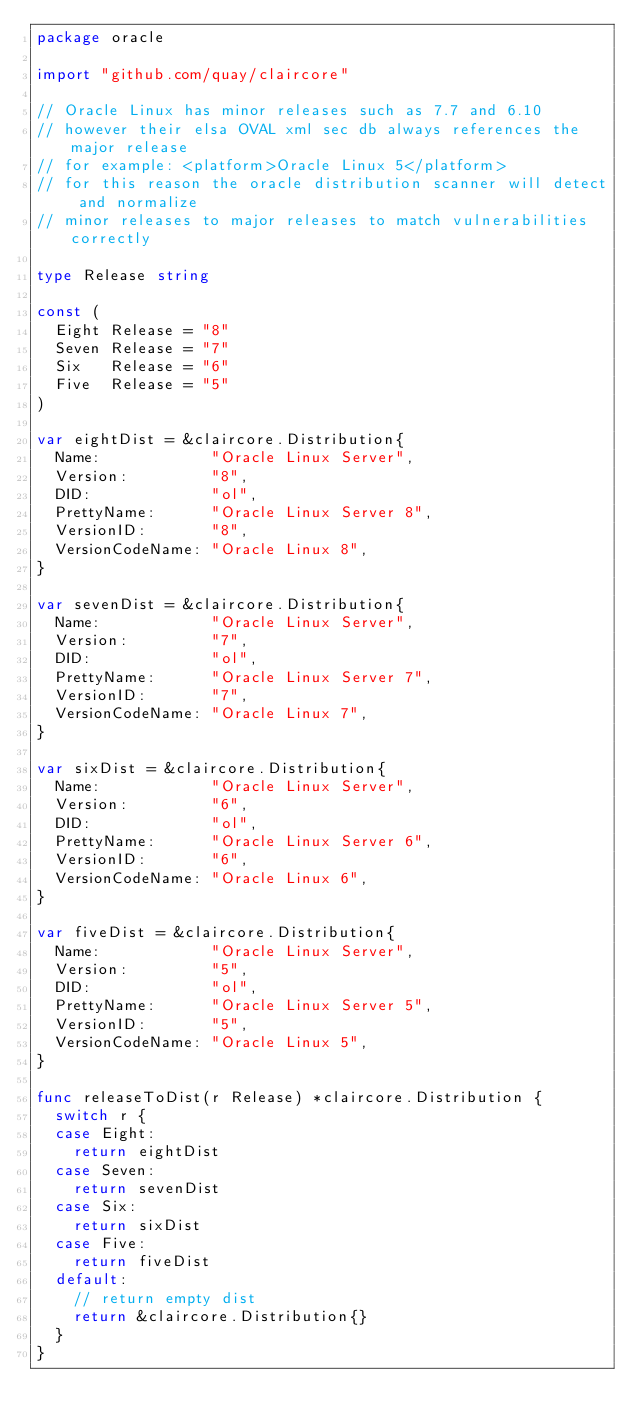<code> <loc_0><loc_0><loc_500><loc_500><_Go_>package oracle

import "github.com/quay/claircore"

// Oracle Linux has minor releases such as 7.7 and 6.10
// however their elsa OVAL xml sec db always references the major release
// for example: <platform>Oracle Linux 5</platform>
// for this reason the oracle distribution scanner will detect and normalize
// minor releases to major releases to match vulnerabilities correctly

type Release string

const (
	Eight Release = "8"
	Seven Release = "7"
	Six   Release = "6"
	Five  Release = "5"
)

var eightDist = &claircore.Distribution{
	Name:            "Oracle Linux Server",
	Version:         "8",
	DID:             "ol",
	PrettyName:      "Oracle Linux Server 8",
	VersionID:       "8",
	VersionCodeName: "Oracle Linux 8",
}

var sevenDist = &claircore.Distribution{
	Name:            "Oracle Linux Server",
	Version:         "7",
	DID:             "ol",
	PrettyName:      "Oracle Linux Server 7",
	VersionID:       "7",
	VersionCodeName: "Oracle Linux 7",
}

var sixDist = &claircore.Distribution{
	Name:            "Oracle Linux Server",
	Version:         "6",
	DID:             "ol",
	PrettyName:      "Oracle Linux Server 6",
	VersionID:       "6",
	VersionCodeName: "Oracle Linux 6",
}

var fiveDist = &claircore.Distribution{
	Name:            "Oracle Linux Server",
	Version:         "5",
	DID:             "ol",
	PrettyName:      "Oracle Linux Server 5",
	VersionID:       "5",
	VersionCodeName: "Oracle Linux 5",
}

func releaseToDist(r Release) *claircore.Distribution {
	switch r {
	case Eight:
		return eightDist
	case Seven:
		return sevenDist
	case Six:
		return sixDist
	case Five:
		return fiveDist
	default:
		// return empty dist
		return &claircore.Distribution{}
	}
}
</code> 